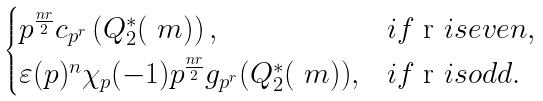Convert formula to latex. <formula><loc_0><loc_0><loc_500><loc_500>\begin{cases} p ^ { \frac { n r } { 2 } } c _ { p ^ { r } } \left ( Q ^ { * } _ { 2 } ( \ m ) \right ) , & i f $ r $ i s e v e n , \\ \varepsilon ( p ) ^ { n } \chi _ { p } ( - 1 ) p ^ { \frac { n r } { 2 } } g _ { p ^ { r } } ( Q ^ { * } _ { 2 } ( \ m ) ) , & i f $ r $ i s o d d . \end{cases}</formula> 